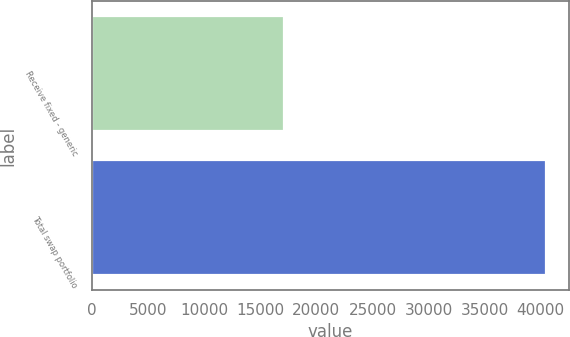Convert chart. <chart><loc_0><loc_0><loc_500><loc_500><bar_chart><fcel>Receive fixed - generic<fcel>Total swap portfolio<nl><fcel>17078<fcel>40466<nl></chart> 